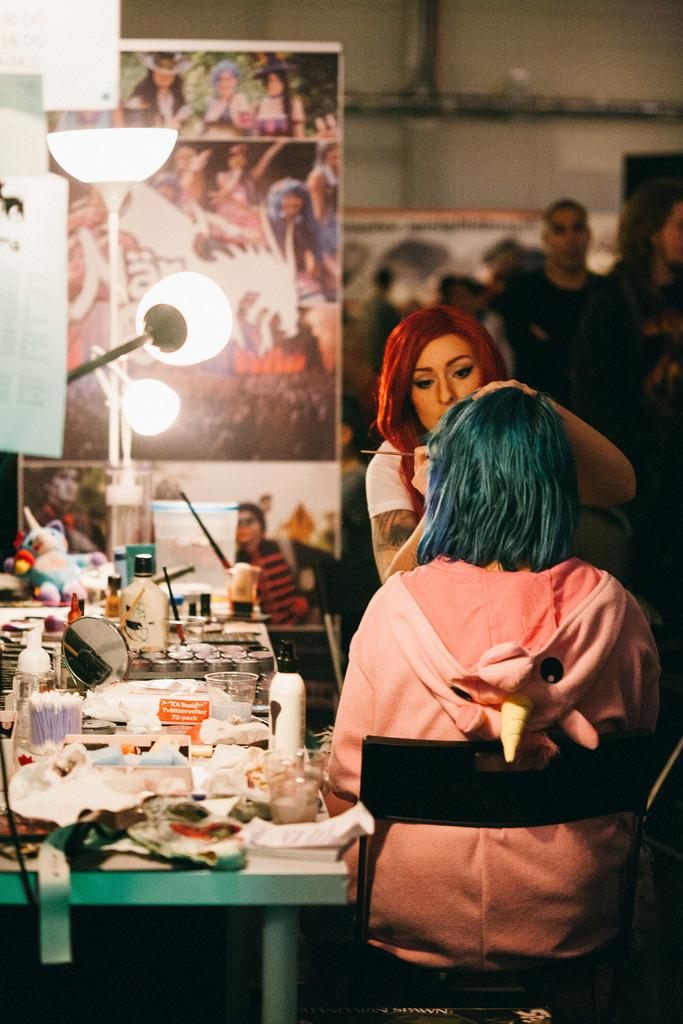How many people are in the group visible in the image? There is a group of people in the image, but the exact number is not specified. What can be seen on the walls in the image? There are posters in the image, which are likely hanging on the walls. What type of containers are visible in the image? There are bottles in the image. What object might be used for personal grooming in the image? There is a mirror in the image, which can be used for personal grooming. Can you describe any other objects present in the image? There are other objects in the image, but their specific nature is not mentioned. What is visible in the background of the image? There is a wall in the background of the image. How many frogs are sitting on the bottles in the image? There are no frogs present in the image; it only features a group of people, posters, bottles, a mirror, and other objects. What type of fruit is being used as a prop by the team in the image? There is no team or fruit present in the image. 